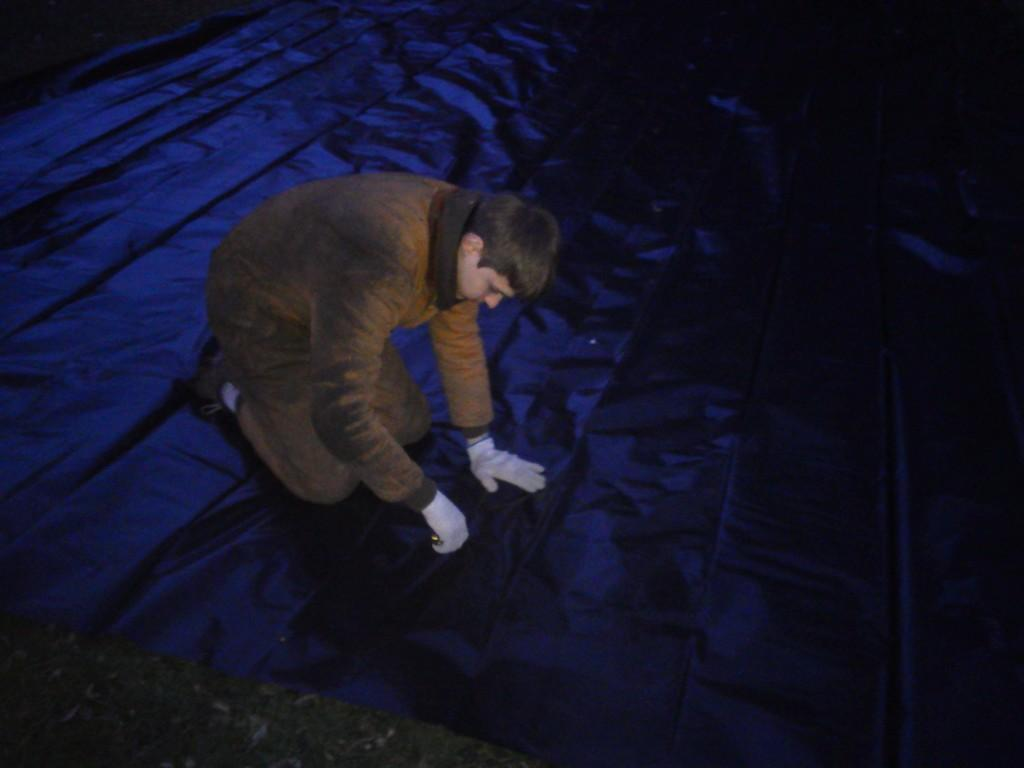Who or what is present in the image? There is a person in the image. What is the person wearing? The person is wearing a brown dress. What other objects or colors can be seen in the image? There is a blue cloth visible in the image. What type of thread is being used to sew the pig in the image? There is no pig present in the image, and therefore no thread or sewing activity can be observed. 